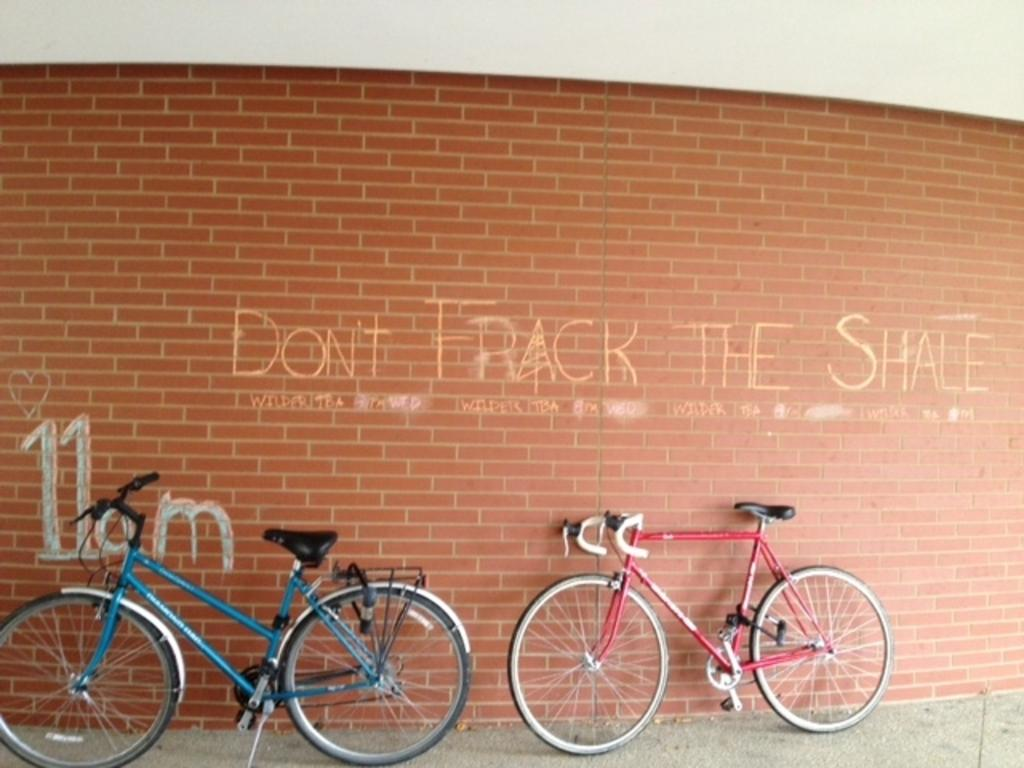How many bicycles are in the image? There are two bicycles in the image. What is the state of the bicycles in the image? The bicycles are parked. What is the background of the image? There is a brick wall in the image. What is written or drawn on the wall? There is text on the wall. Where are the bicycles parked? The bicycles are parked on the road. Can you see a baby playing with a clam near the bicycles in the image? There is no baby or clam present in the image. Who is the owner of the bicycles in the image? The image does not provide information about the owner of the bicycles. 